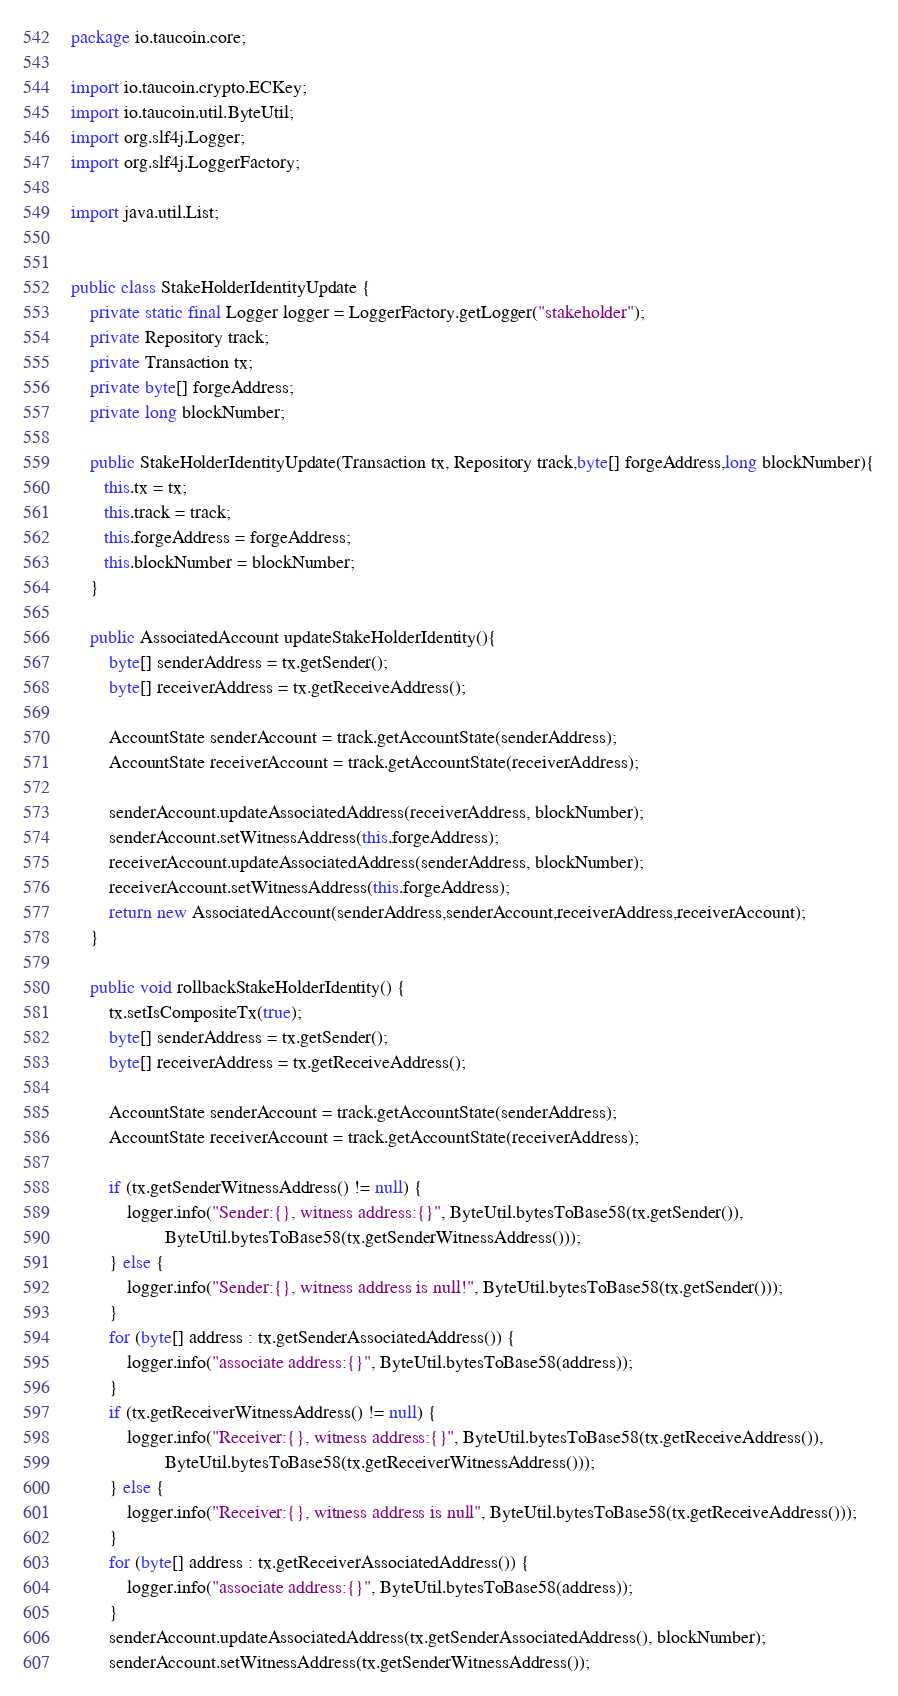<code> <loc_0><loc_0><loc_500><loc_500><_Java_>package io.taucoin.core;

import io.taucoin.crypto.ECKey;
import io.taucoin.util.ByteUtil;
import org.slf4j.Logger;
import org.slf4j.LoggerFactory;

import java.util.List;


public class StakeHolderIdentityUpdate {
    private static final Logger logger = LoggerFactory.getLogger("stakeholder");
    private Repository track;
    private Transaction tx;
    private byte[] forgeAddress;
    private long blockNumber;

    public StakeHolderIdentityUpdate(Transaction tx, Repository track,byte[] forgeAddress,long blockNumber){
       this.tx = tx;
       this.track = track;
       this.forgeAddress = forgeAddress;
       this.blockNumber = blockNumber;
    }

    public AssociatedAccount updateStakeHolderIdentity(){
        byte[] senderAddress = tx.getSender();
        byte[] receiverAddress = tx.getReceiveAddress();

        AccountState senderAccount = track.getAccountState(senderAddress);
        AccountState receiverAccount = track.getAccountState(receiverAddress);

        senderAccount.updateAssociatedAddress(receiverAddress, blockNumber);
        senderAccount.setWitnessAddress(this.forgeAddress);
        receiverAccount.updateAssociatedAddress(senderAddress, blockNumber);
        receiverAccount.setWitnessAddress(this.forgeAddress);
        return new AssociatedAccount(senderAddress,senderAccount,receiverAddress,receiverAccount);
    }

    public void rollbackStakeHolderIdentity() {
        tx.setIsCompositeTx(true);
        byte[] senderAddress = tx.getSender();
        byte[] receiverAddress = tx.getReceiveAddress();

        AccountState senderAccount = track.getAccountState(senderAddress);
        AccountState receiverAccount = track.getAccountState(receiverAddress);

        if (tx.getSenderWitnessAddress() != null) {
            logger.info("Sender:{}, witness address:{}", ByteUtil.bytesToBase58(tx.getSender()),
                    ByteUtil.bytesToBase58(tx.getSenderWitnessAddress()));
        } else {
            logger.info("Sender:{}, witness address is null!", ByteUtil.bytesToBase58(tx.getSender()));
        }
        for (byte[] address : tx.getSenderAssociatedAddress()) {
            logger.info("associate address:{}", ByteUtil.bytesToBase58(address));
        }
        if (tx.getReceiverWitnessAddress() != null) {
            logger.info("Receiver:{}, witness address:{}", ByteUtil.bytesToBase58(tx.getReceiveAddress()),
                    ByteUtil.bytesToBase58(tx.getReceiverWitnessAddress()));
        } else {
            logger.info("Receiver:{}, witness address is null", ByteUtil.bytesToBase58(tx.getReceiveAddress()));
        }
        for (byte[] address : tx.getReceiverAssociatedAddress()) {
            logger.info("associate address:{}", ByteUtil.bytesToBase58(address));
        }
        senderAccount.updateAssociatedAddress(tx.getSenderAssociatedAddress(), blockNumber);
        senderAccount.setWitnessAddress(tx.getSenderWitnessAddress());</code> 